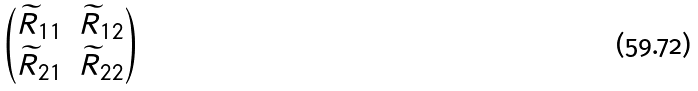Convert formula to latex. <formula><loc_0><loc_0><loc_500><loc_500>\begin{pmatrix} \widetilde { R } _ { 1 1 } & \widetilde { R } _ { 1 2 } \\ \widetilde { R } _ { 2 1 } & \widetilde { R } _ { 2 2 } \end{pmatrix}</formula> 